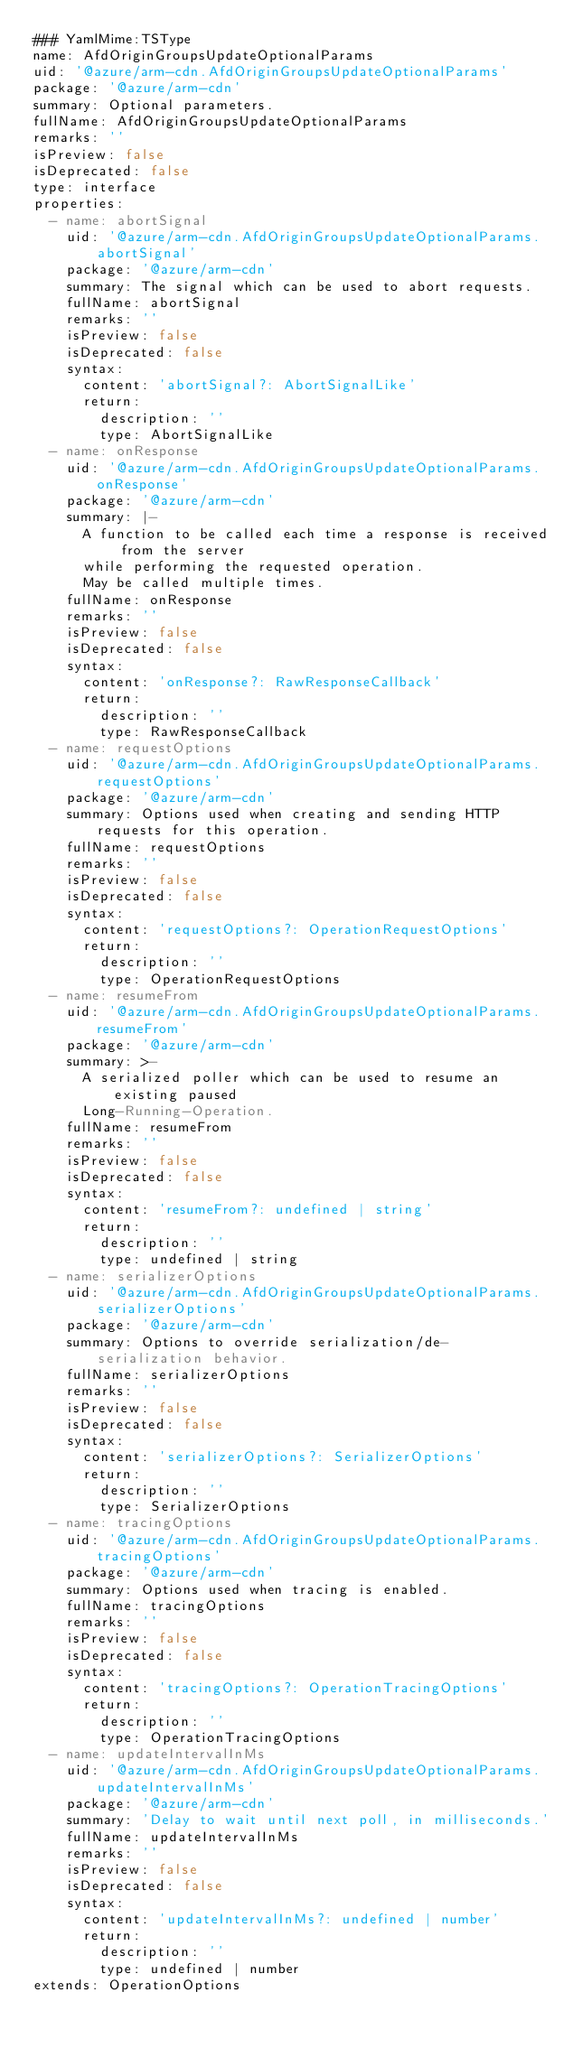Convert code to text. <code><loc_0><loc_0><loc_500><loc_500><_YAML_>### YamlMime:TSType
name: AfdOriginGroupsUpdateOptionalParams
uid: '@azure/arm-cdn.AfdOriginGroupsUpdateOptionalParams'
package: '@azure/arm-cdn'
summary: Optional parameters.
fullName: AfdOriginGroupsUpdateOptionalParams
remarks: ''
isPreview: false
isDeprecated: false
type: interface
properties:
  - name: abortSignal
    uid: '@azure/arm-cdn.AfdOriginGroupsUpdateOptionalParams.abortSignal'
    package: '@azure/arm-cdn'
    summary: The signal which can be used to abort requests.
    fullName: abortSignal
    remarks: ''
    isPreview: false
    isDeprecated: false
    syntax:
      content: 'abortSignal?: AbortSignalLike'
      return:
        description: ''
        type: AbortSignalLike
  - name: onResponse
    uid: '@azure/arm-cdn.AfdOriginGroupsUpdateOptionalParams.onResponse'
    package: '@azure/arm-cdn'
    summary: |-
      A function to be called each time a response is received from the server
      while performing the requested operation.
      May be called multiple times.
    fullName: onResponse
    remarks: ''
    isPreview: false
    isDeprecated: false
    syntax:
      content: 'onResponse?: RawResponseCallback'
      return:
        description: ''
        type: RawResponseCallback
  - name: requestOptions
    uid: '@azure/arm-cdn.AfdOriginGroupsUpdateOptionalParams.requestOptions'
    package: '@azure/arm-cdn'
    summary: Options used when creating and sending HTTP requests for this operation.
    fullName: requestOptions
    remarks: ''
    isPreview: false
    isDeprecated: false
    syntax:
      content: 'requestOptions?: OperationRequestOptions'
      return:
        description: ''
        type: OperationRequestOptions
  - name: resumeFrom
    uid: '@azure/arm-cdn.AfdOriginGroupsUpdateOptionalParams.resumeFrom'
    package: '@azure/arm-cdn'
    summary: >-
      A serialized poller which can be used to resume an existing paused
      Long-Running-Operation.
    fullName: resumeFrom
    remarks: ''
    isPreview: false
    isDeprecated: false
    syntax:
      content: 'resumeFrom?: undefined | string'
      return:
        description: ''
        type: undefined | string
  - name: serializerOptions
    uid: '@azure/arm-cdn.AfdOriginGroupsUpdateOptionalParams.serializerOptions'
    package: '@azure/arm-cdn'
    summary: Options to override serialization/de-serialization behavior.
    fullName: serializerOptions
    remarks: ''
    isPreview: false
    isDeprecated: false
    syntax:
      content: 'serializerOptions?: SerializerOptions'
      return:
        description: ''
        type: SerializerOptions
  - name: tracingOptions
    uid: '@azure/arm-cdn.AfdOriginGroupsUpdateOptionalParams.tracingOptions'
    package: '@azure/arm-cdn'
    summary: Options used when tracing is enabled.
    fullName: tracingOptions
    remarks: ''
    isPreview: false
    isDeprecated: false
    syntax:
      content: 'tracingOptions?: OperationTracingOptions'
      return:
        description: ''
        type: OperationTracingOptions
  - name: updateIntervalInMs
    uid: '@azure/arm-cdn.AfdOriginGroupsUpdateOptionalParams.updateIntervalInMs'
    package: '@azure/arm-cdn'
    summary: 'Delay to wait until next poll, in milliseconds.'
    fullName: updateIntervalInMs
    remarks: ''
    isPreview: false
    isDeprecated: false
    syntax:
      content: 'updateIntervalInMs?: undefined | number'
      return:
        description: ''
        type: undefined | number
extends: OperationOptions
</code> 